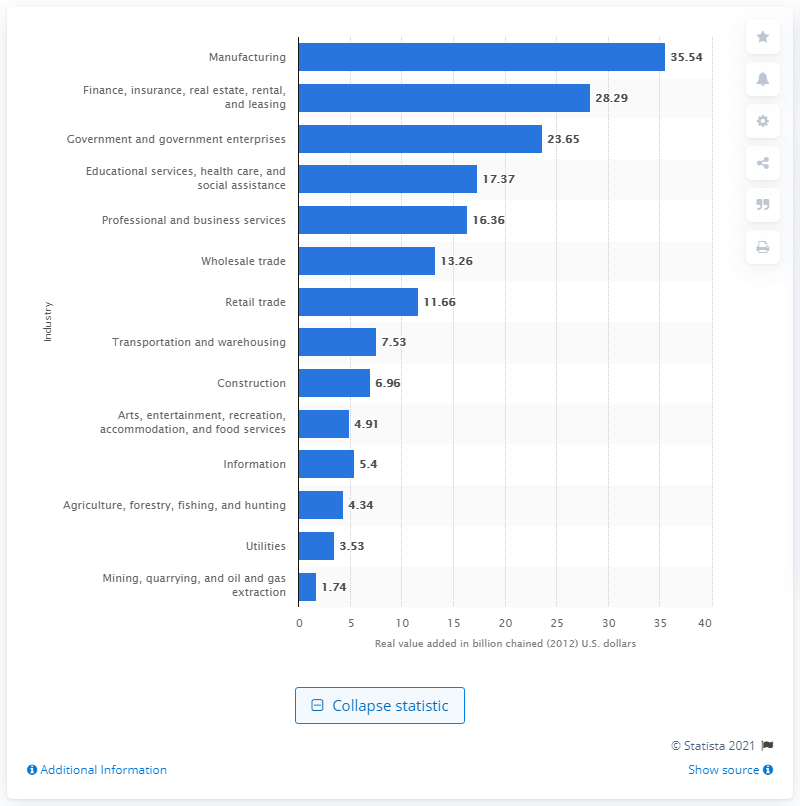How much value did the manufacturing industry add to Kentucky's GDP in 2020? In 2020, the manufacturing industry was a significant contributor to Kentucky's GDP, amounting to a substantial 35.54 billion, when measured in chained 2012 U.S. dollars. 